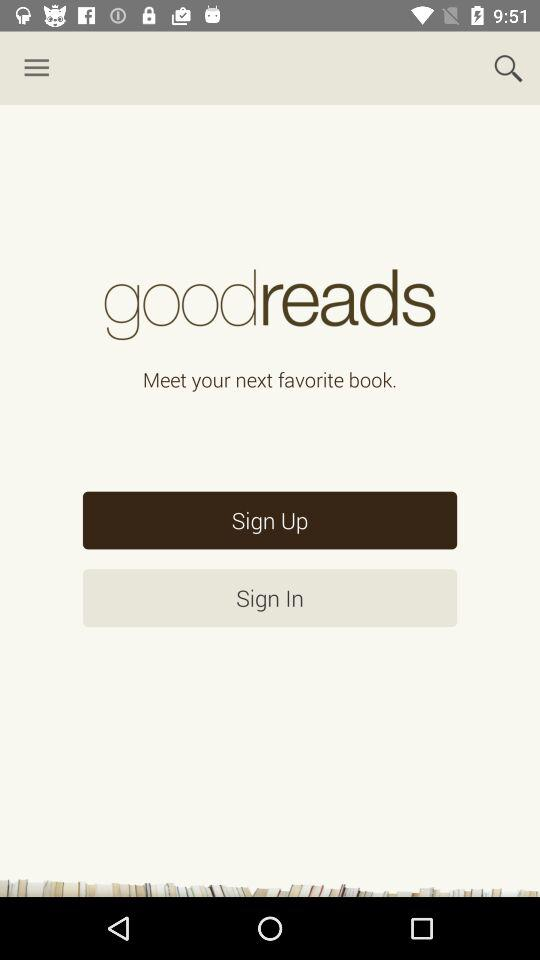What is the app name? The app name is "goodreads". 